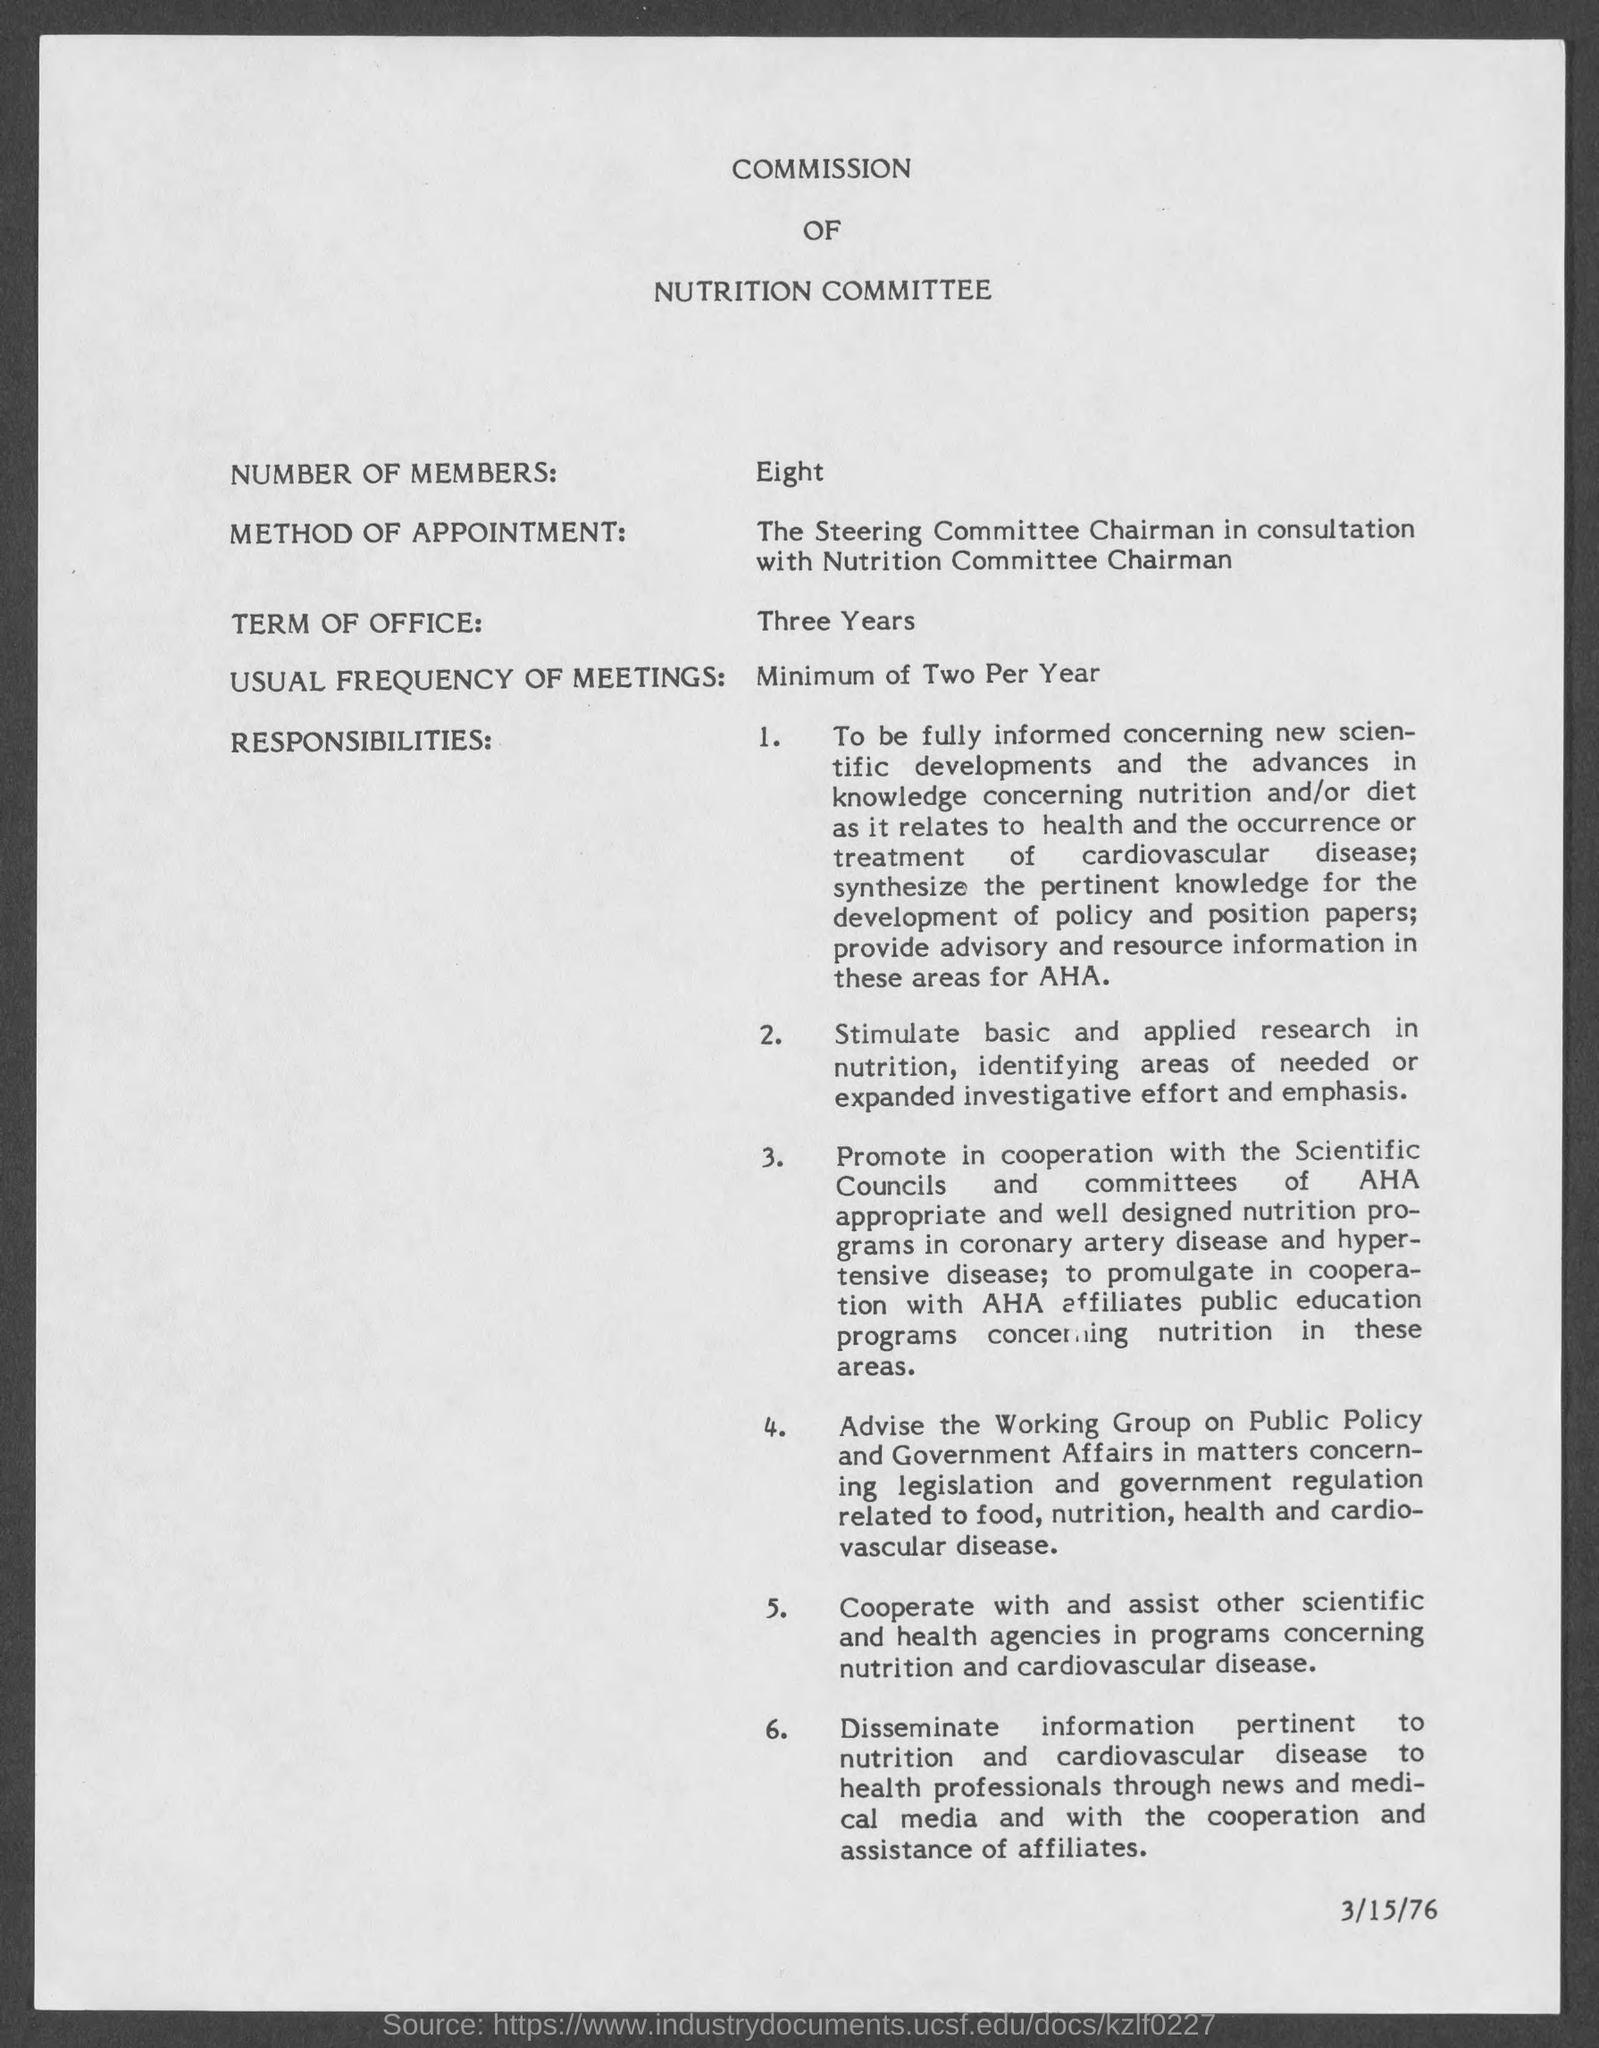What is the Title of the document?
Offer a terse response. COMMISSION OF NUTRITION COMMITTEE. What are the Number of Members?
Give a very brief answer. Eight. What is the Term of Office?
Make the answer very short. Three Years. What is the Usual frequency of meetings?
Your response must be concise. Minimum of Two Per Year. 